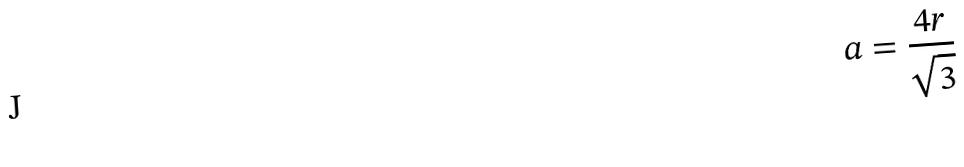Convert formula to latex. <formula><loc_0><loc_0><loc_500><loc_500>a = \frac { 4 r } { \sqrt { 3 } }</formula> 